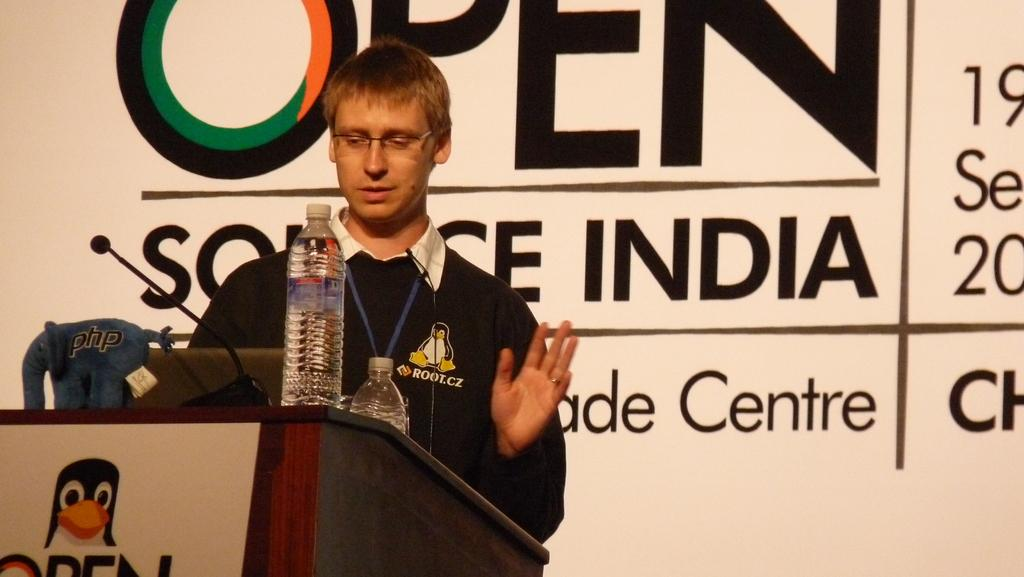<image>
Write a terse but informative summary of the picture. A person giving a lecture at Open Source India. 